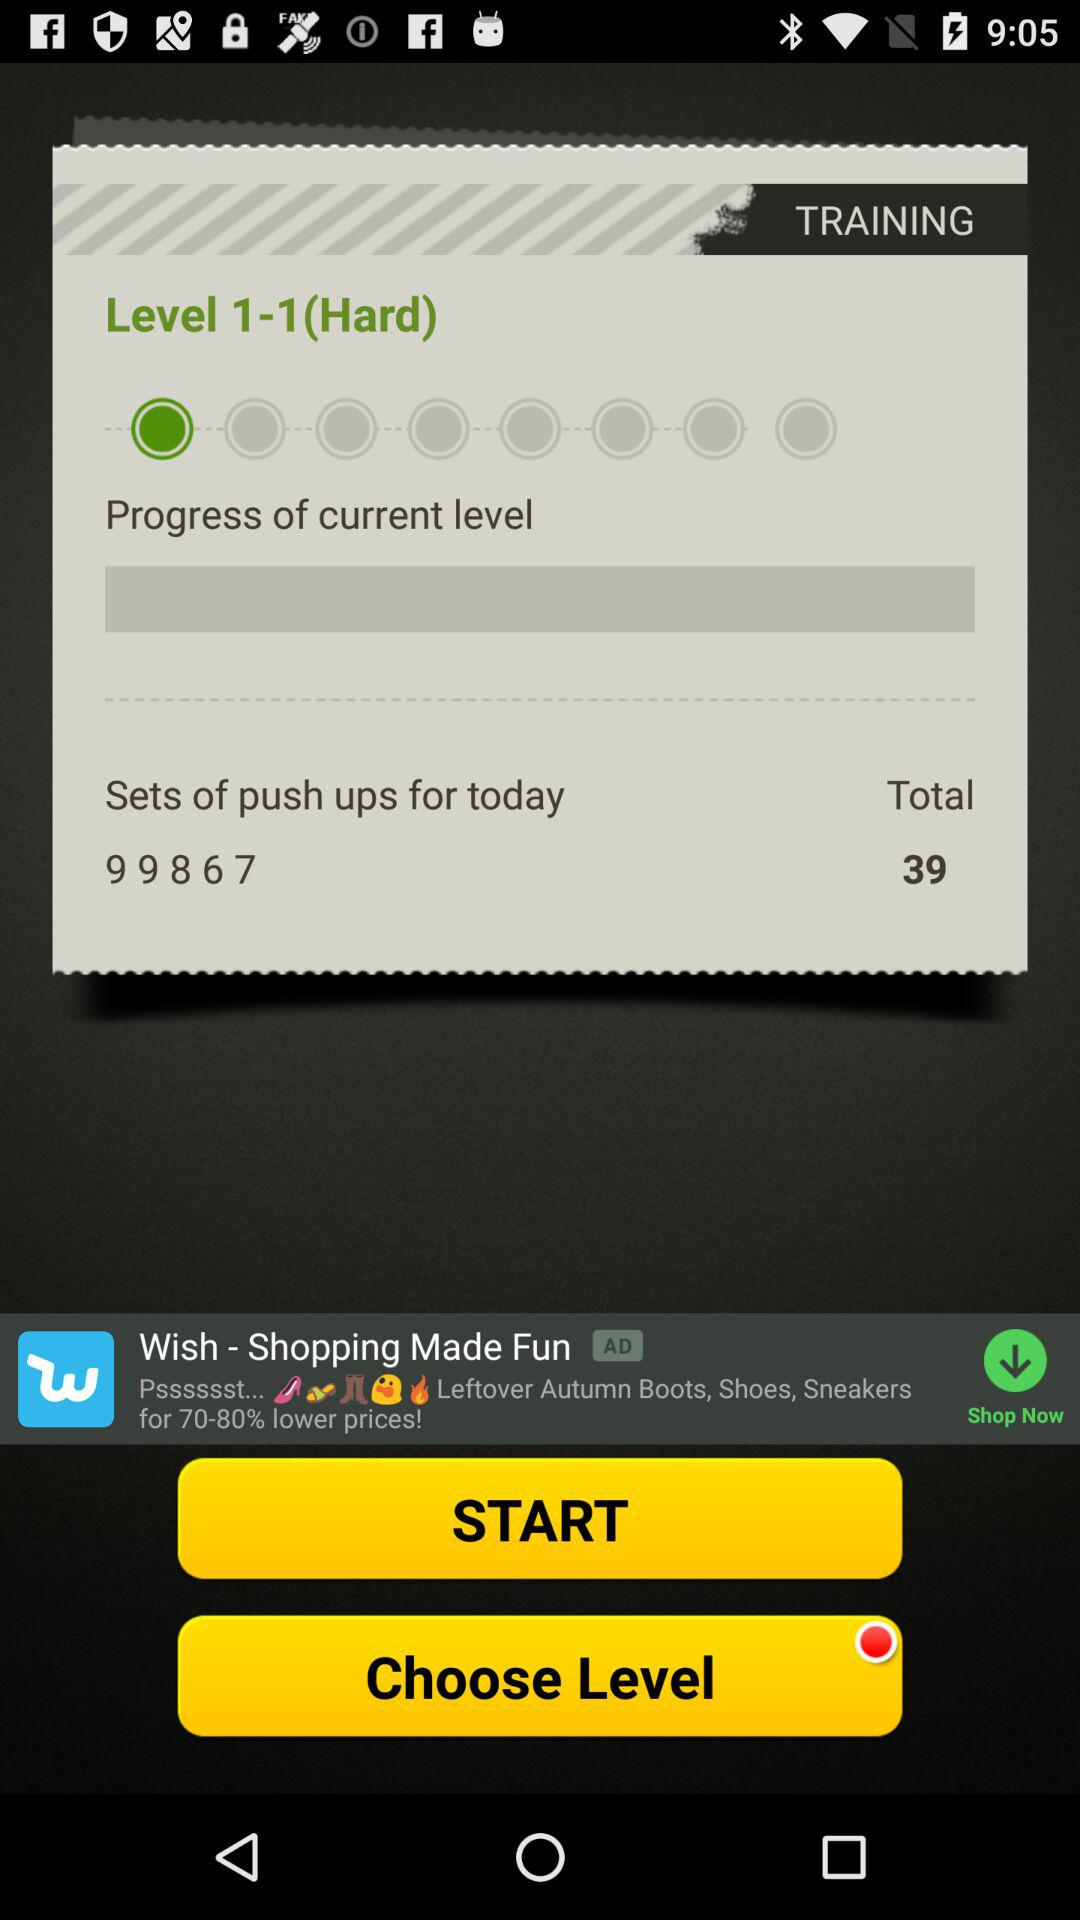What's the level type? The level type is hard. 